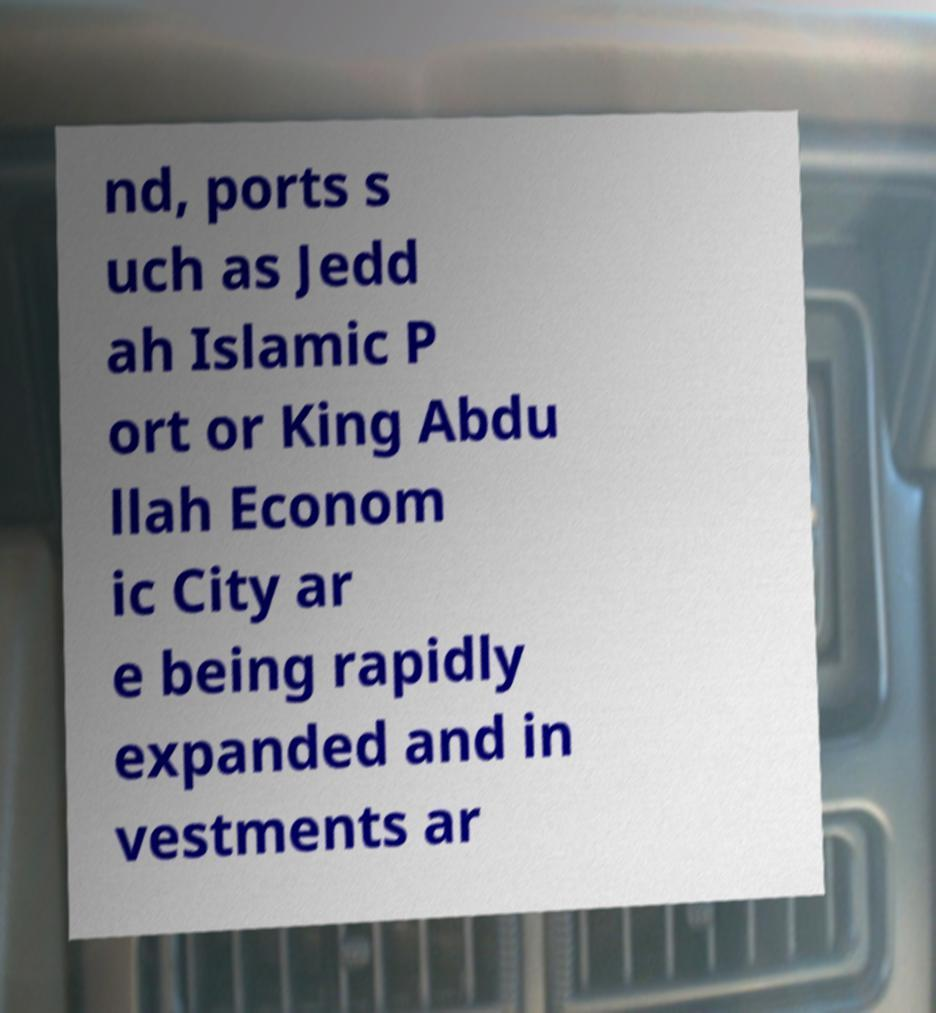Please identify and transcribe the text found in this image. nd, ports s uch as Jedd ah Islamic P ort or King Abdu llah Econom ic City ar e being rapidly expanded and in vestments ar 